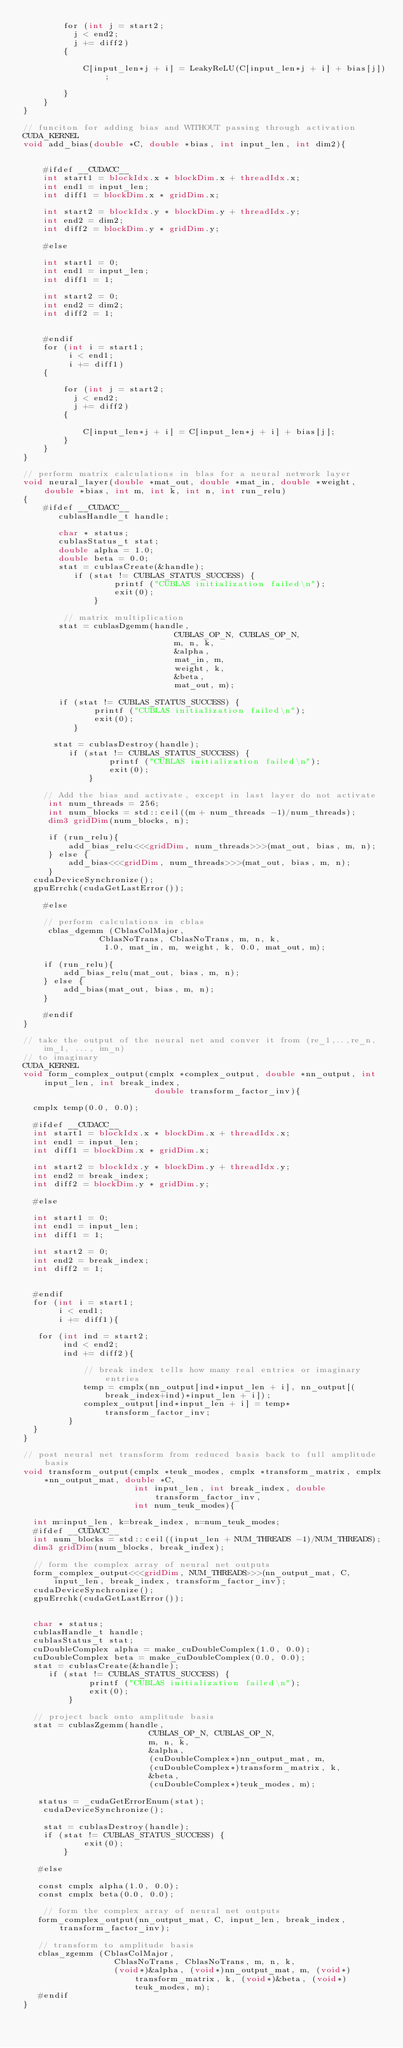Convert code to text. <code><loc_0><loc_0><loc_500><loc_500><_Cuda_>        for (int j = start2;
          j < end2;
          j += diff2)
        {

            C[input_len*j + i] = LeakyReLU(C[input_len*j + i] + bias[j]);

        }
    }
}

// funciton for adding bias and WITHOUT passing through activation
CUDA_KERNEL
void add_bias(double *C, double *bias, int input_len, int dim2){


    #ifdef __CUDACC__
    int start1 = blockIdx.x * blockDim.x + threadIdx.x;
    int end1 = input_len;
    int diff1 = blockDim.x * gridDim.x;

    int start2 = blockIdx.y * blockDim.y + threadIdx.y;
    int end2 = dim2;
    int diff2 = blockDim.y * gridDim.y;

    #else

    int start1 = 0;
    int end1 = input_len;
    int diff1 = 1;

    int start2 = 0;
    int end2 = dim2;
    int diff2 = 1;


    #endif
    for (int i = start1;
         i < end1;
         i += diff1)
    {

        for (int j = start2;
          j < end2;
          j += diff2)
        {

            C[input_len*j + i] = C[input_len*j + i] + bias[j];
        }
    }
}

// perform matrix calculations in blas for a neural network layer
void neural_layer(double *mat_out, double *mat_in, double *weight, double *bias, int m, int k, int n, int run_relu)
{
    #ifdef __CUDACC__
       cublasHandle_t handle;

       char * status;
       cublasStatus_t stat;
       double alpha = 1.0;
       double beta = 0.0;
       stat = cublasCreate(&handle);
          if (stat != CUBLAS_STATUS_SUCCESS) {
                  printf ("CUBLAS initialization failed\n");
                  exit(0);
              }

        // matrix multiplication
       stat = cublasDgemm(handle,
                              CUBLAS_OP_N, CUBLAS_OP_N,
                              m, n, k,
                              &alpha,
                              mat_in, m,
                              weight, k,
                              &beta,
                              mat_out, m);

       if (stat != CUBLAS_STATUS_SUCCESS) {
              printf ("CUBLAS initialization failed\n");
              exit(0);
          }

      stat = cublasDestroy(handle);
         if (stat != CUBLAS_STATUS_SUCCESS) {
                 printf ("CUBLAS initialization failed\n");
                 exit(0);
             }

    // Add the bias and activate, except in last layer do not activate
     int num_threads = 256;
     int num_blocks = std::ceil((m + num_threads -1)/num_threads);
     dim3 gridDim(num_blocks, n);

     if (run_relu){
         add_bias_relu<<<gridDim, num_threads>>>(mat_out, bias, m, n);
     } else {
         add_bias<<<gridDim, num_threads>>>(mat_out, bias, m, n);
     }
  cudaDeviceSynchronize();
  gpuErrchk(cudaGetLastError());

    #else

    // perform calculations in cblas
     cblas_dgemm (CblasColMajor,
               CblasNoTrans, CblasNoTrans, m, n, k,
                1.0, mat_in, m, weight, k, 0.0, mat_out, m);

    if (run_relu){
        add_bias_relu(mat_out, bias, m, n);
    } else {
        add_bias(mat_out, bias, m, n);
    }

    #endif
}

// take the output of the neural net and conver it from (re_1,..,re_n, im_1, ..., im_n)
// to imaginary
CUDA_KERNEL
void form_complex_output(cmplx *complex_output, double *nn_output, int input_len, int break_index,
                          double transform_factor_inv){

  cmplx temp(0.0, 0.0);

  #ifdef __CUDACC__
  int start1 = blockIdx.x * blockDim.x + threadIdx.x;
  int end1 = input_len;
  int diff1 = blockDim.x * gridDim.x;

  int start2 = blockIdx.y * blockDim.y + threadIdx.y;
  int end2 = break_index;
  int diff2 = blockDim.y * gridDim.y;

  #else

  int start1 = 0;
  int end1 = input_len;
  int diff1 = 1;

  int start2 = 0;
  int end2 = break_index;
  int diff2 = 1;


  #endif
  for (int i = start1;
       i < end1;
       i += diff1){

   for (int ind = start2;
        ind < end2;
        ind += diff2){

            // break index tells how many real entries or imaginary entries
            temp = cmplx(nn_output[ind*input_len + i], nn_output[(break_index+ind)*input_len + i]);
            complex_output[ind*input_len + i] = temp*transform_factor_inv;
         }
  }
}

// post neural net transform from reduced basis back to full amplitude basis
void transform_output(cmplx *teuk_modes, cmplx *transform_matrix, cmplx *nn_output_mat, double *C,
                      int input_len, int break_index, double transform_factor_inv,
                      int num_teuk_modes){

  int m=input_len, k=break_index, n=num_teuk_modes;
  #ifdef __CUDACC__
  int num_blocks = std::ceil((input_len + NUM_THREADS -1)/NUM_THREADS);
  dim3 gridDim(num_blocks, break_index);

  // form the complex array of neural net outputs
  form_complex_output<<<gridDim, NUM_THREADS>>>(nn_output_mat, C, input_len, break_index, transform_factor_inv);
  cudaDeviceSynchronize();
  gpuErrchk(cudaGetLastError());


  char * status;
  cublasHandle_t handle;
  cublasStatus_t stat;
  cuDoubleComplex alpha = make_cuDoubleComplex(1.0, 0.0);
  cuDoubleComplex beta = make_cuDoubleComplex(0.0, 0.0);
  stat = cublasCreate(&handle);
     if (stat != CUBLAS_STATUS_SUCCESS) {
             printf ("CUBLAS initialization failed\n");
             exit(0);
         }

  // project back onto amplitude basis
  stat = cublasZgemm(handle,
                         CUBLAS_OP_N, CUBLAS_OP_N,
                         m, n, k,
                         &alpha,
                         (cuDoubleComplex*)nn_output_mat, m,
                         (cuDoubleComplex*)transform_matrix, k,
                         &beta,
                         (cuDoubleComplex*)teuk_modes, m);

   status = _cudaGetErrorEnum(stat);
    cudaDeviceSynchronize();

    stat = cublasDestroy(handle);
    if (stat != CUBLAS_STATUS_SUCCESS) {
            exit(0);
        }

   #else

   const cmplx alpha(1.0, 0.0);
   const cmplx beta(0.0, 0.0);

    // form the complex array of neural net outputs
   form_complex_output(nn_output_mat, C, input_len, break_index, transform_factor_inv);

   // transform to amplitude basis
   cblas_zgemm (CblasColMajor,
                  CblasNoTrans, CblasNoTrans, m, n, k,
                  (void*)&alpha, (void*)nn_output_mat, m, (void*)transform_matrix, k, (void*)&beta, (void*)teuk_modes, m);
   #endif
}
</code> 